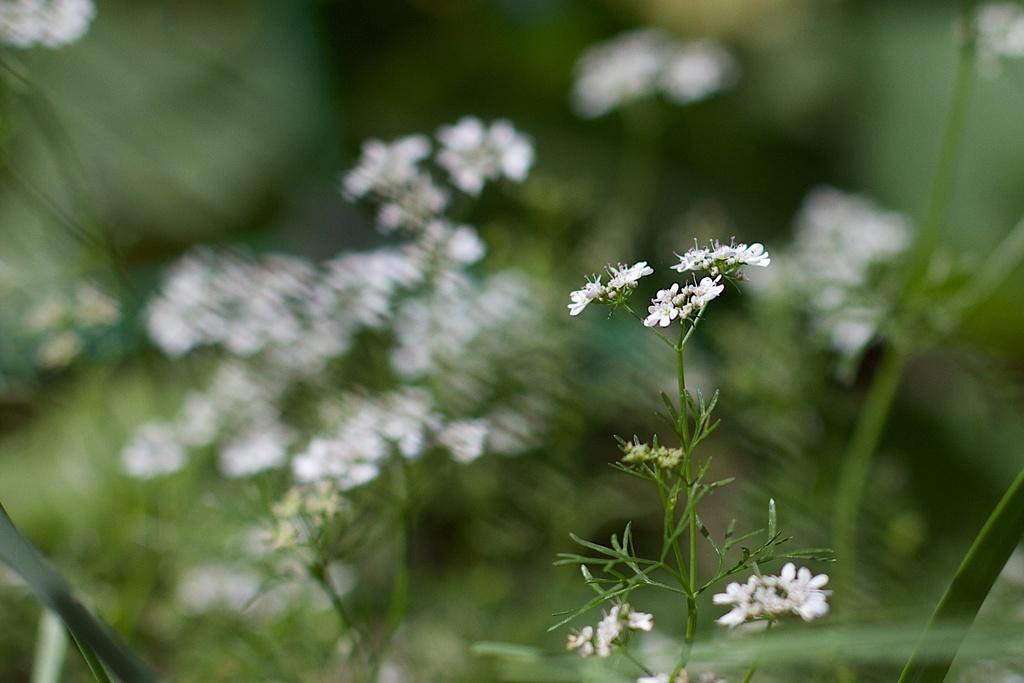Could you give a brief overview of what you see in this image? Here in this picture we can see flowers present on the plants over there. 